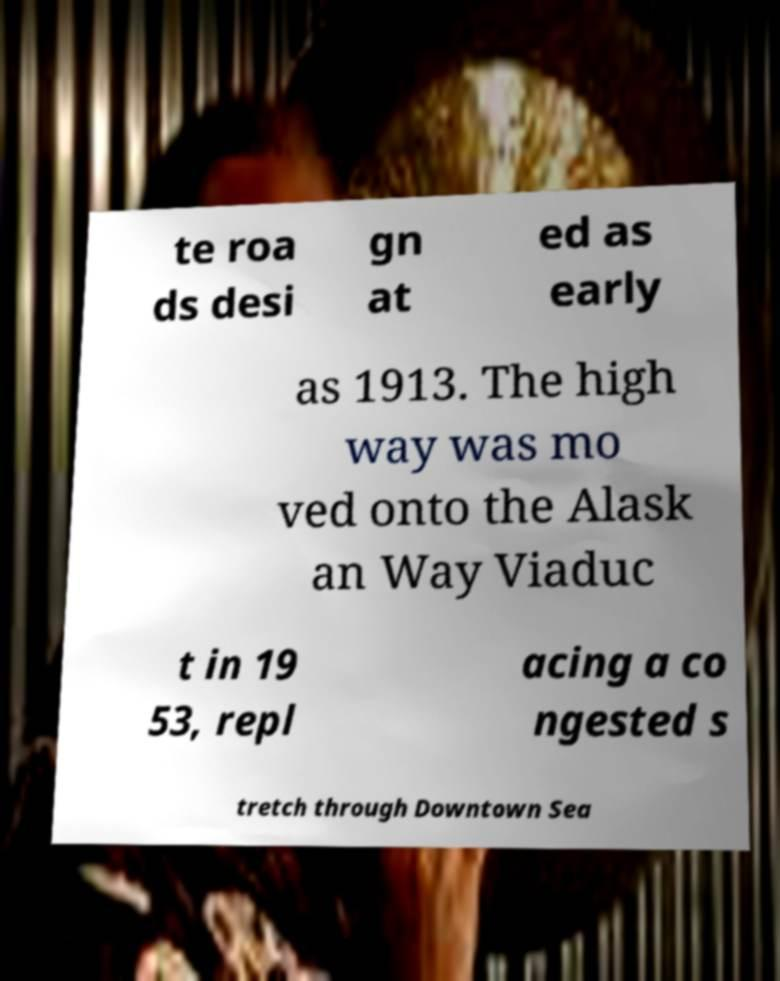Please identify and transcribe the text found in this image. te roa ds desi gn at ed as early as 1913. The high way was mo ved onto the Alask an Way Viaduc t in 19 53, repl acing a co ngested s tretch through Downtown Sea 